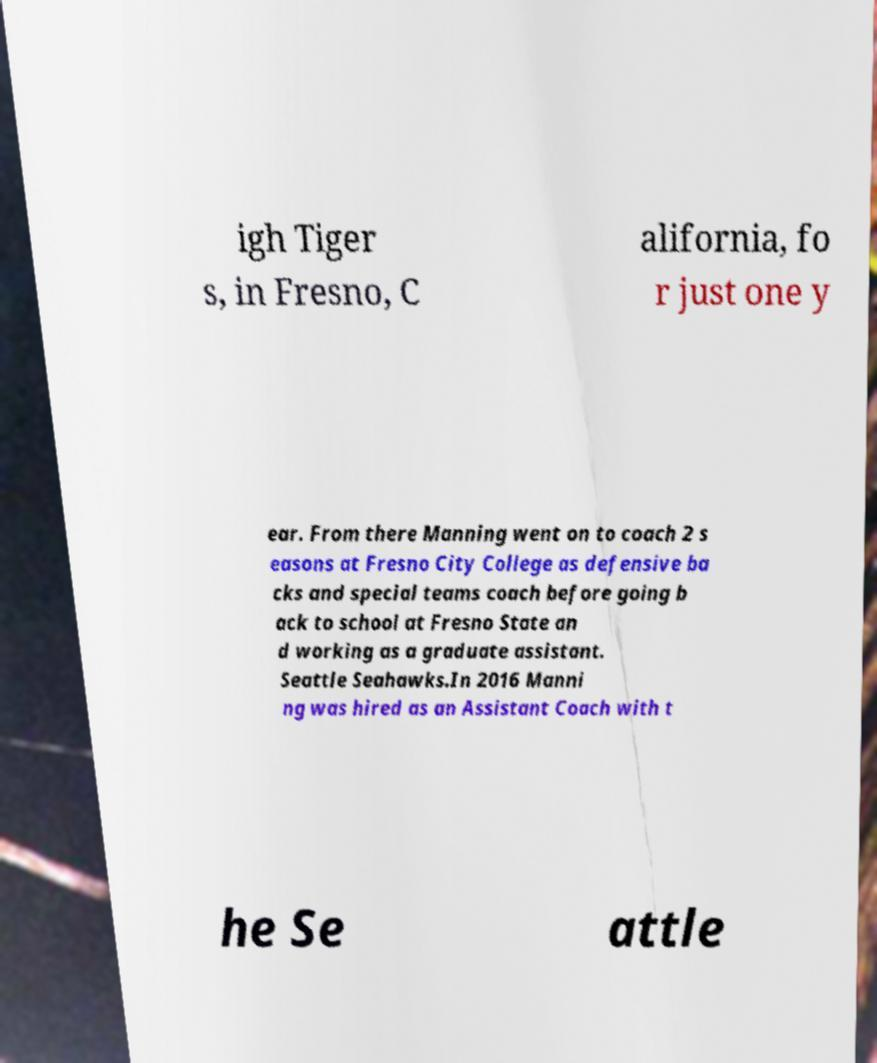Can you read and provide the text displayed in the image?This photo seems to have some interesting text. Can you extract and type it out for me? igh Tiger s, in Fresno, C alifornia, fo r just one y ear. From there Manning went on to coach 2 s easons at Fresno City College as defensive ba cks and special teams coach before going b ack to school at Fresno State an d working as a graduate assistant. Seattle Seahawks.In 2016 Manni ng was hired as an Assistant Coach with t he Se attle 